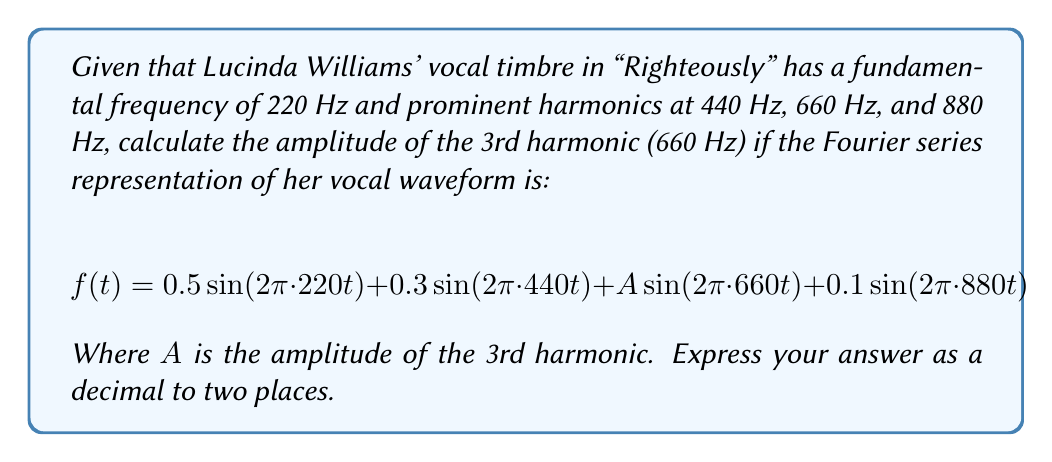Provide a solution to this math problem. To solve this problem, we need to understand the Fourier series representation of a periodic signal. In this case, Lucinda Williams' vocal timbre is represented as a sum of sine waves at different frequencies (harmonics).

The general form of a Fourier series for a periodic signal is:

$$f(t) = \sum_{n=1}^{\infty} A_n \sin(2\pi n f_0 t)$$

Where:
- $f_0$ is the fundamental frequency
- $n$ is the harmonic number
- $A_n$ is the amplitude of the nth harmonic

In our given equation:
$$f(t) = 0.5 \sin(2\pi \cdot 220t) + 0.3 \sin(2\pi \cdot 440t) + A \sin(2\pi \cdot 660t) + 0.1 \sin(2\pi \cdot 880t)$$

We can identify:
1. Fundamental frequency (1st harmonic): 220 Hz with amplitude 0.5
2. 2nd harmonic: 440 Hz with amplitude 0.3
3. 3rd harmonic: 660 Hz with amplitude A (what we're solving for)
4. 4th harmonic: 880 Hz with amplitude 0.1

The question asks for the amplitude of the 3rd harmonic, which is represented by $A$ in the equation.

To find $A$, we simply need to read its value from the given Fourier series representation. The amplitude of the 3rd harmonic (660 Hz) is directly represented by $A$ in the equation.
Answer: $A = 0.20$ 